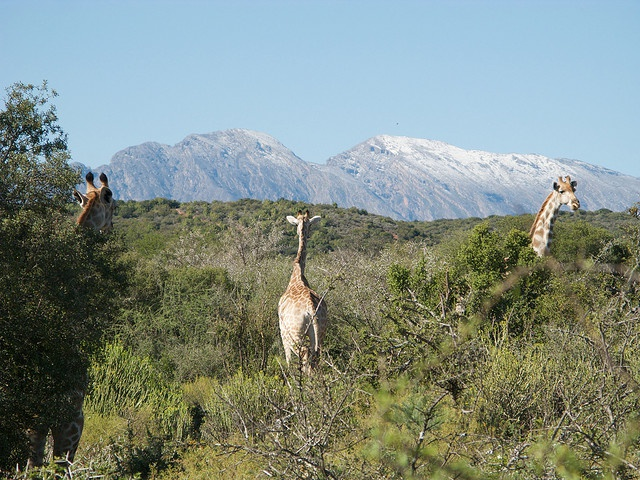Describe the objects in this image and their specific colors. I can see giraffe in lightblue, ivory, gray, tan, and black tones, giraffe in lightblue, ivory, and tan tones, and giraffe in lightblue, black, gray, and maroon tones in this image. 